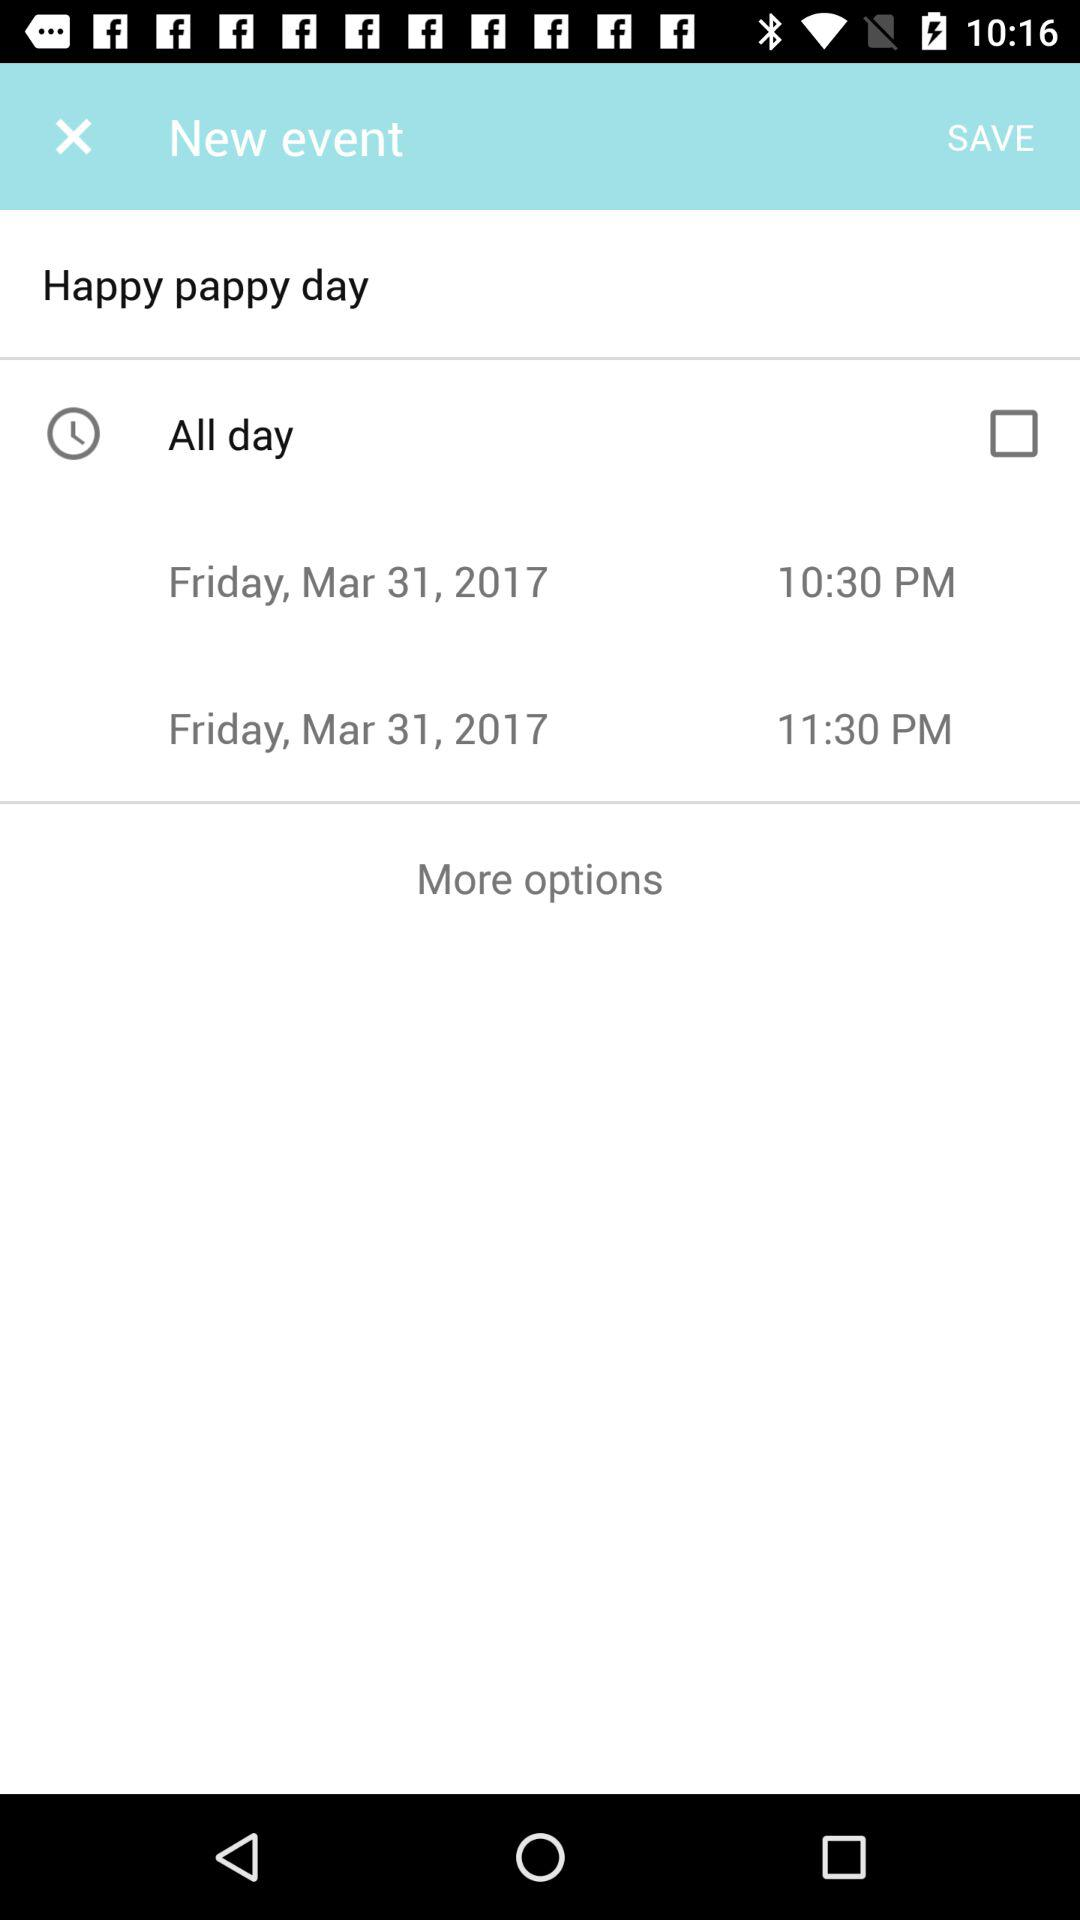What is the timing of happy pappy day?
When the provided information is insufficient, respond with <no answer>. <no answer> 